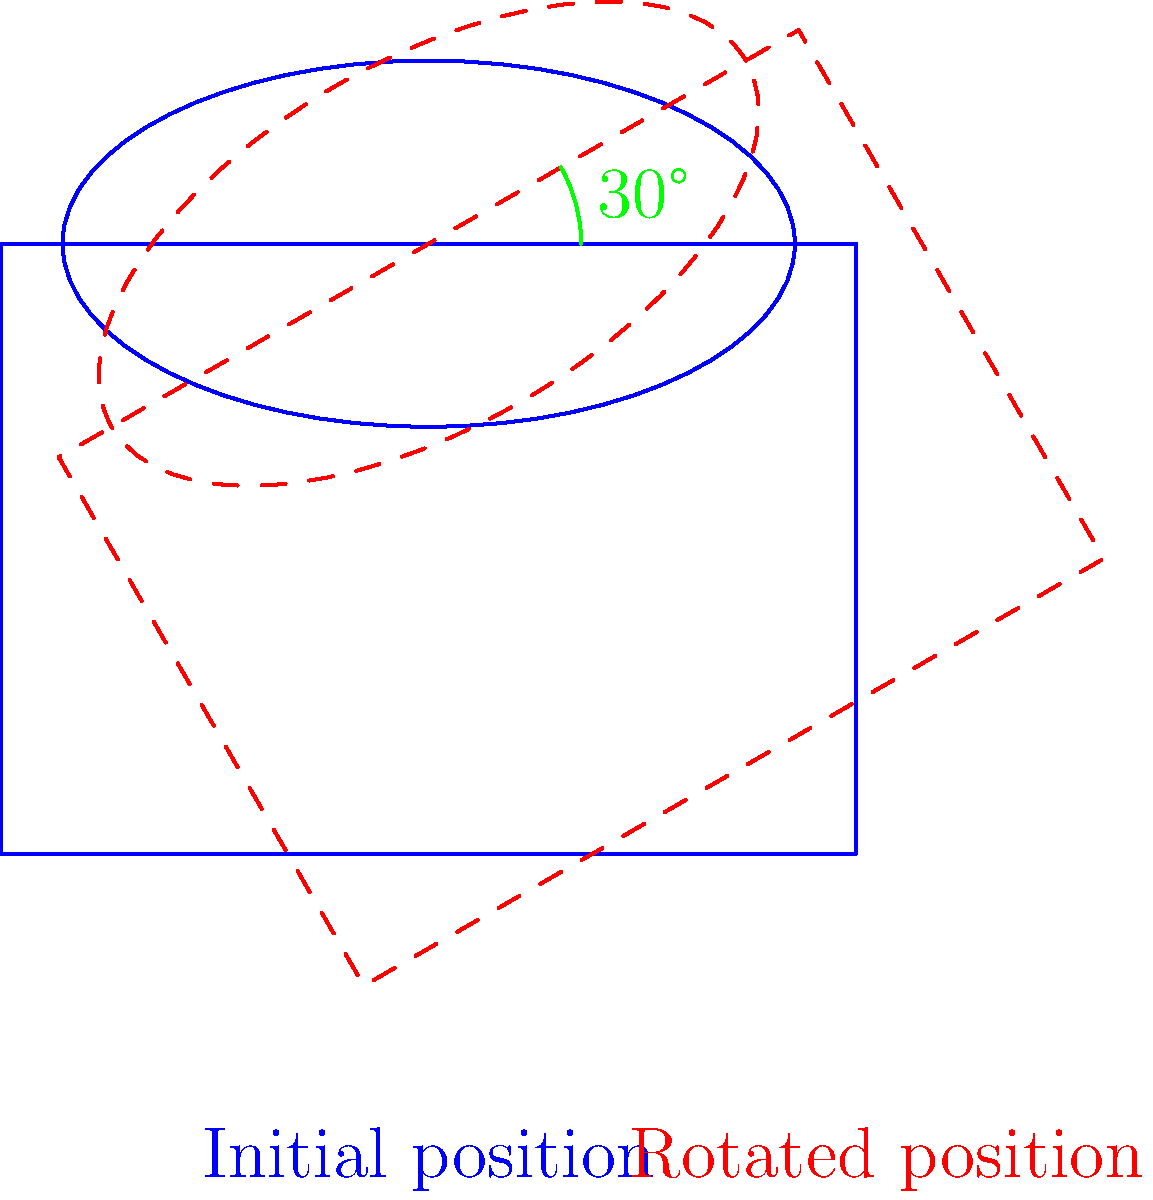In a tennis match, you notice that your friend's younger brother needs to adjust his racket position for an optimal forehand swing. The current racket position is shown in blue, and the ideal position is shown in red (dashed). By how many degrees should he rotate his racket clockwise to achieve the optimal position? To solve this problem, we need to follow these steps:

1. Observe the initial position of the racket (blue solid line) and the optimal position (red dashed line).

2. Notice that there is an angle marked between these two positions.

3. The angle is clearly labeled as 30°.

4. Since the question asks for clockwise rotation, and the optimal position (red dashed line) is rotated clockwise from the initial position (blue solid line), we can directly use the given angle.

5. Therefore, the racket should be rotated 30° clockwise to achieve the optimal position for the forehand swing.

This rotation will align the racket with the ideal angle for maximum power and control in the forehand stroke, which is crucial for improving the younger brother's tennis performance.
Answer: 30° 